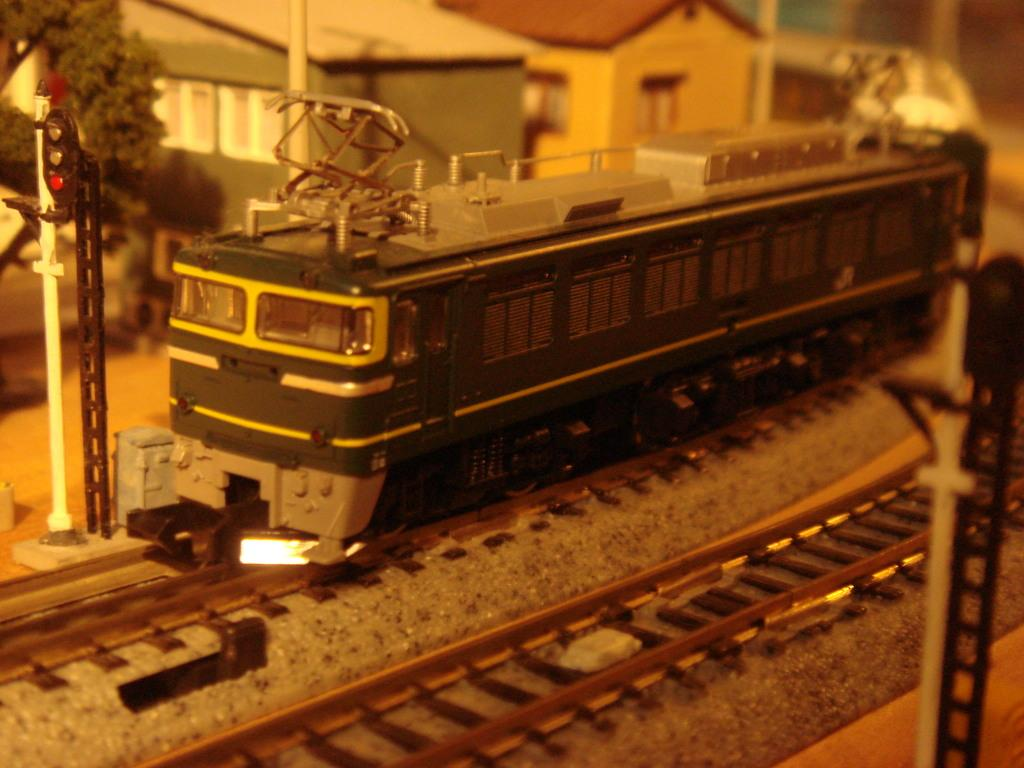What is located at the bottom of the image? There is a railway track at the bottom of the image. What is in the middle of the image? There is a train in the middle of the image. What can be seen at the top of the image? There are buildings and a tree at the top of the image. What type of grade is the train receiving in the image? There is no indication of a grade or any evaluation of the train in the image. How does the tree's haircut look in the image? Trees do not have hair, so there is no haircut to evaluate in the image. 